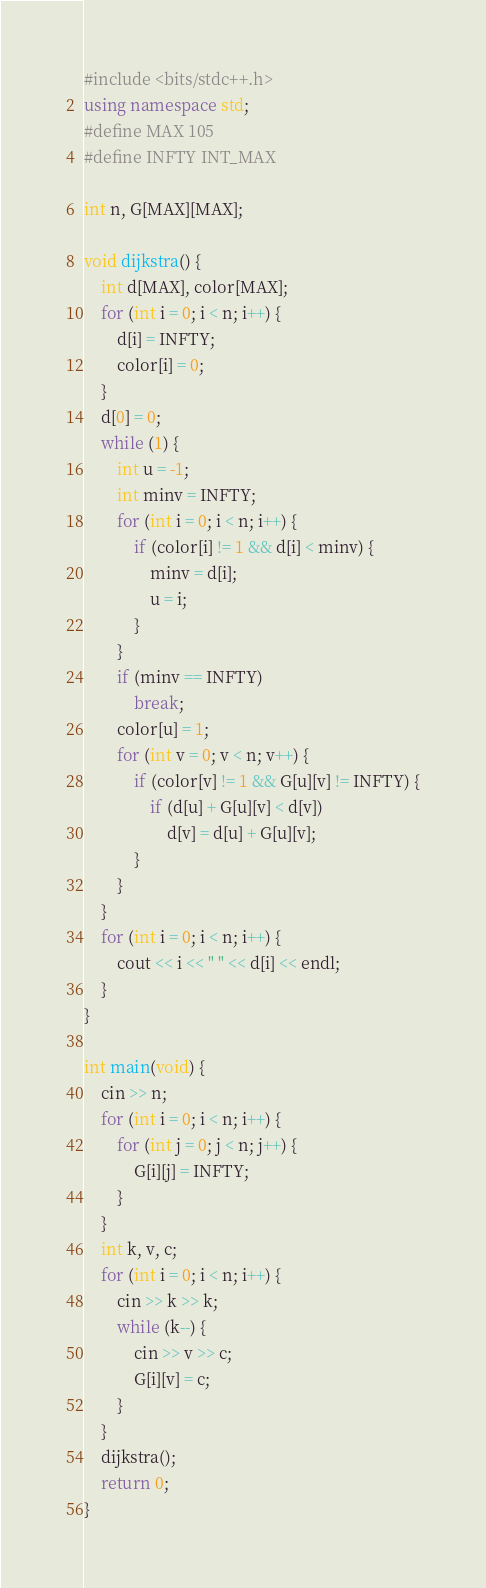<code> <loc_0><loc_0><loc_500><loc_500><_C++_>#include <bits/stdc++.h>
using namespace std;
#define MAX 105
#define INFTY INT_MAX

int n, G[MAX][MAX];

void dijkstra() {
    int d[MAX], color[MAX];
    for (int i = 0; i < n; i++) {
        d[i] = INFTY;
        color[i] = 0;
    }
    d[0] = 0;
    while (1) {
        int u = -1;
        int minv = INFTY;
        for (int i = 0; i < n; i++) {
            if (color[i] != 1 && d[i] < minv) {
                minv = d[i];
                u = i;
            }
        }
        if (minv == INFTY)
            break;
        color[u] = 1;
        for (int v = 0; v < n; v++) {
            if (color[v] != 1 && G[u][v] != INFTY) {
                if (d[u] + G[u][v] < d[v])
                    d[v] = d[u] + G[u][v];
            }
        }
    }
    for (int i = 0; i < n; i++) {
        cout << i << " " << d[i] << endl;
    }
}

int main(void) {
    cin >> n;
    for (int i = 0; i < n; i++) {
        for (int j = 0; j < n; j++) {
            G[i][j] = INFTY;
        }
    }
    int k, v, c;
    for (int i = 0; i < n; i++) {
        cin >> k >> k;
        while (k--) {
            cin >> v >> c;
            G[i][v] = c;
        }
    }
    dijkstra();
    return 0;
}
</code> 